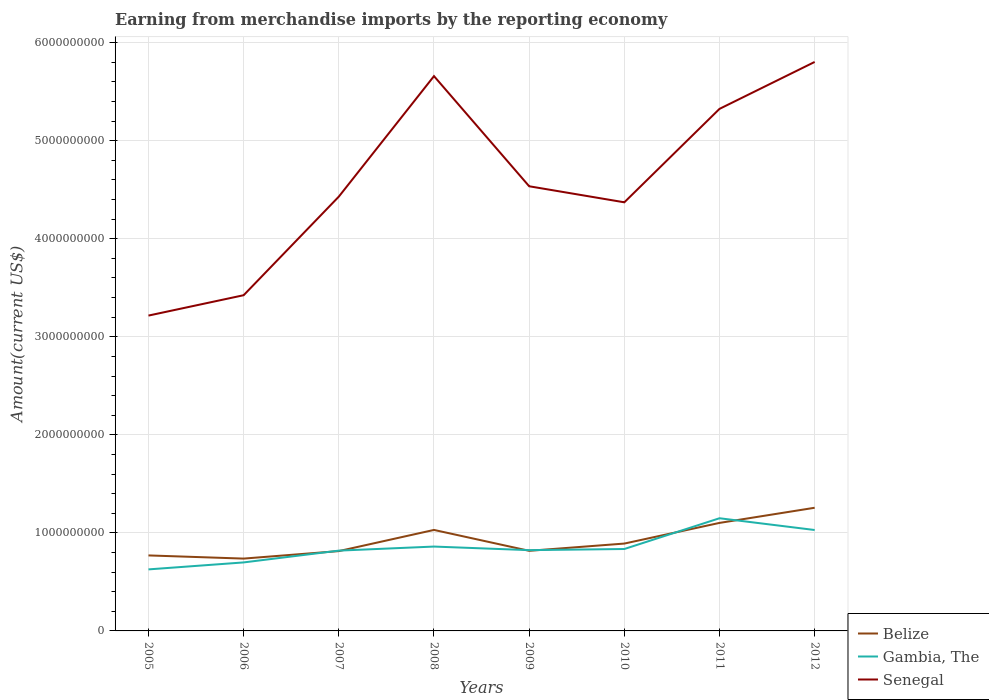Across all years, what is the maximum amount earned from merchandise imports in Belize?
Offer a terse response. 7.38e+08. What is the total amount earned from merchandise imports in Senegal in the graph?
Provide a short and direct response. -2.08e+08. What is the difference between the highest and the second highest amount earned from merchandise imports in Senegal?
Give a very brief answer. 2.59e+09. Is the amount earned from merchandise imports in Senegal strictly greater than the amount earned from merchandise imports in Gambia, The over the years?
Offer a very short reply. No. How many years are there in the graph?
Give a very brief answer. 8. What is the difference between two consecutive major ticks on the Y-axis?
Offer a very short reply. 1.00e+09. Are the values on the major ticks of Y-axis written in scientific E-notation?
Your answer should be very brief. No. Does the graph contain any zero values?
Offer a very short reply. No. How are the legend labels stacked?
Offer a terse response. Vertical. What is the title of the graph?
Provide a short and direct response. Earning from merchandise imports by the reporting economy. Does "Jamaica" appear as one of the legend labels in the graph?
Offer a very short reply. No. What is the label or title of the X-axis?
Provide a succinct answer. Years. What is the label or title of the Y-axis?
Ensure brevity in your answer.  Amount(current US$). What is the Amount(current US$) in Belize in 2005?
Your response must be concise. 7.70e+08. What is the Amount(current US$) of Gambia, The in 2005?
Make the answer very short. 6.28e+08. What is the Amount(current US$) in Senegal in 2005?
Provide a short and direct response. 3.22e+09. What is the Amount(current US$) in Belize in 2006?
Keep it short and to the point. 7.38e+08. What is the Amount(current US$) of Gambia, The in 2006?
Provide a succinct answer. 6.99e+08. What is the Amount(current US$) in Senegal in 2006?
Provide a short and direct response. 3.42e+09. What is the Amount(current US$) in Belize in 2007?
Make the answer very short. 8.14e+08. What is the Amount(current US$) of Gambia, The in 2007?
Provide a short and direct response. 8.19e+08. What is the Amount(current US$) of Senegal in 2007?
Keep it short and to the point. 4.43e+09. What is the Amount(current US$) in Belize in 2008?
Your response must be concise. 1.03e+09. What is the Amount(current US$) in Gambia, The in 2008?
Keep it short and to the point. 8.60e+08. What is the Amount(current US$) of Senegal in 2008?
Your response must be concise. 5.66e+09. What is the Amount(current US$) of Belize in 2009?
Your answer should be compact. 8.17e+08. What is the Amount(current US$) of Gambia, The in 2009?
Provide a short and direct response. 8.24e+08. What is the Amount(current US$) in Senegal in 2009?
Offer a terse response. 4.54e+09. What is the Amount(current US$) in Belize in 2010?
Your answer should be very brief. 8.91e+08. What is the Amount(current US$) in Gambia, The in 2010?
Provide a succinct answer. 8.36e+08. What is the Amount(current US$) in Senegal in 2010?
Keep it short and to the point. 4.37e+09. What is the Amount(current US$) of Belize in 2011?
Your answer should be compact. 1.10e+09. What is the Amount(current US$) in Gambia, The in 2011?
Your response must be concise. 1.15e+09. What is the Amount(current US$) in Senegal in 2011?
Your answer should be very brief. 5.33e+09. What is the Amount(current US$) in Belize in 2012?
Your answer should be compact. 1.26e+09. What is the Amount(current US$) of Gambia, The in 2012?
Your answer should be very brief. 1.03e+09. What is the Amount(current US$) of Senegal in 2012?
Your answer should be very brief. 5.80e+09. Across all years, what is the maximum Amount(current US$) of Belize?
Provide a succinct answer. 1.26e+09. Across all years, what is the maximum Amount(current US$) of Gambia, The?
Your answer should be very brief. 1.15e+09. Across all years, what is the maximum Amount(current US$) in Senegal?
Your answer should be compact. 5.80e+09. Across all years, what is the minimum Amount(current US$) in Belize?
Offer a very short reply. 7.38e+08. Across all years, what is the minimum Amount(current US$) in Gambia, The?
Provide a short and direct response. 6.28e+08. Across all years, what is the minimum Amount(current US$) in Senegal?
Your answer should be very brief. 3.22e+09. What is the total Amount(current US$) in Belize in the graph?
Your answer should be compact. 7.42e+09. What is the total Amount(current US$) in Gambia, The in the graph?
Give a very brief answer. 6.84e+09. What is the total Amount(current US$) of Senegal in the graph?
Keep it short and to the point. 3.68e+1. What is the difference between the Amount(current US$) of Belize in 2005 and that in 2006?
Keep it short and to the point. 3.23e+07. What is the difference between the Amount(current US$) in Gambia, The in 2005 and that in 2006?
Offer a terse response. -7.11e+07. What is the difference between the Amount(current US$) in Senegal in 2005 and that in 2006?
Offer a very short reply. -2.08e+08. What is the difference between the Amount(current US$) of Belize in 2005 and that in 2007?
Offer a very short reply. -4.42e+07. What is the difference between the Amount(current US$) of Gambia, The in 2005 and that in 2007?
Your answer should be compact. -1.91e+08. What is the difference between the Amount(current US$) in Senegal in 2005 and that in 2007?
Offer a terse response. -1.21e+09. What is the difference between the Amount(current US$) in Belize in 2005 and that in 2008?
Make the answer very short. -2.60e+08. What is the difference between the Amount(current US$) in Gambia, The in 2005 and that in 2008?
Your answer should be very brief. -2.33e+08. What is the difference between the Amount(current US$) of Senegal in 2005 and that in 2008?
Your response must be concise. -2.44e+09. What is the difference between the Amount(current US$) in Belize in 2005 and that in 2009?
Offer a terse response. -4.71e+07. What is the difference between the Amount(current US$) of Gambia, The in 2005 and that in 2009?
Make the answer very short. -1.96e+08. What is the difference between the Amount(current US$) of Senegal in 2005 and that in 2009?
Provide a short and direct response. -1.32e+09. What is the difference between the Amount(current US$) of Belize in 2005 and that in 2010?
Make the answer very short. -1.21e+08. What is the difference between the Amount(current US$) in Gambia, The in 2005 and that in 2010?
Keep it short and to the point. -2.08e+08. What is the difference between the Amount(current US$) in Senegal in 2005 and that in 2010?
Keep it short and to the point. -1.16e+09. What is the difference between the Amount(current US$) of Belize in 2005 and that in 2011?
Your answer should be very brief. -3.32e+08. What is the difference between the Amount(current US$) in Gambia, The in 2005 and that in 2011?
Your response must be concise. -5.22e+08. What is the difference between the Amount(current US$) of Senegal in 2005 and that in 2011?
Offer a terse response. -2.11e+09. What is the difference between the Amount(current US$) in Belize in 2005 and that in 2012?
Your answer should be compact. -4.86e+08. What is the difference between the Amount(current US$) of Gambia, The in 2005 and that in 2012?
Your answer should be compact. -4.02e+08. What is the difference between the Amount(current US$) in Senegal in 2005 and that in 2012?
Give a very brief answer. -2.59e+09. What is the difference between the Amount(current US$) of Belize in 2006 and that in 2007?
Provide a short and direct response. -7.64e+07. What is the difference between the Amount(current US$) in Gambia, The in 2006 and that in 2007?
Your answer should be compact. -1.20e+08. What is the difference between the Amount(current US$) of Senegal in 2006 and that in 2007?
Offer a very short reply. -1.01e+09. What is the difference between the Amount(current US$) in Belize in 2006 and that in 2008?
Keep it short and to the point. -2.92e+08. What is the difference between the Amount(current US$) of Gambia, The in 2006 and that in 2008?
Offer a terse response. -1.62e+08. What is the difference between the Amount(current US$) in Senegal in 2006 and that in 2008?
Keep it short and to the point. -2.23e+09. What is the difference between the Amount(current US$) in Belize in 2006 and that in 2009?
Make the answer very short. -7.94e+07. What is the difference between the Amount(current US$) of Gambia, The in 2006 and that in 2009?
Your response must be concise. -1.25e+08. What is the difference between the Amount(current US$) in Senegal in 2006 and that in 2009?
Make the answer very short. -1.11e+09. What is the difference between the Amount(current US$) in Belize in 2006 and that in 2010?
Your answer should be very brief. -1.53e+08. What is the difference between the Amount(current US$) in Gambia, The in 2006 and that in 2010?
Offer a terse response. -1.37e+08. What is the difference between the Amount(current US$) in Senegal in 2006 and that in 2010?
Give a very brief answer. -9.48e+08. What is the difference between the Amount(current US$) of Belize in 2006 and that in 2011?
Provide a short and direct response. -3.64e+08. What is the difference between the Amount(current US$) in Gambia, The in 2006 and that in 2011?
Your response must be concise. -4.51e+08. What is the difference between the Amount(current US$) in Senegal in 2006 and that in 2011?
Ensure brevity in your answer.  -1.90e+09. What is the difference between the Amount(current US$) in Belize in 2006 and that in 2012?
Make the answer very short. -5.18e+08. What is the difference between the Amount(current US$) in Gambia, The in 2006 and that in 2012?
Offer a terse response. -3.31e+08. What is the difference between the Amount(current US$) of Senegal in 2006 and that in 2012?
Provide a succinct answer. -2.38e+09. What is the difference between the Amount(current US$) of Belize in 2007 and that in 2008?
Keep it short and to the point. -2.16e+08. What is the difference between the Amount(current US$) of Gambia, The in 2007 and that in 2008?
Give a very brief answer. -4.14e+07. What is the difference between the Amount(current US$) of Senegal in 2007 and that in 2008?
Provide a succinct answer. -1.23e+09. What is the difference between the Amount(current US$) in Belize in 2007 and that in 2009?
Keep it short and to the point. -2.95e+06. What is the difference between the Amount(current US$) in Gambia, The in 2007 and that in 2009?
Provide a succinct answer. -4.97e+06. What is the difference between the Amount(current US$) of Senegal in 2007 and that in 2009?
Give a very brief answer. -1.05e+08. What is the difference between the Amount(current US$) in Belize in 2007 and that in 2010?
Keep it short and to the point. -7.68e+07. What is the difference between the Amount(current US$) of Gambia, The in 2007 and that in 2010?
Offer a very short reply. -1.66e+07. What is the difference between the Amount(current US$) in Senegal in 2007 and that in 2010?
Your answer should be compact. 5.82e+07. What is the difference between the Amount(current US$) of Belize in 2007 and that in 2011?
Offer a very short reply. -2.88e+08. What is the difference between the Amount(current US$) in Gambia, The in 2007 and that in 2011?
Offer a terse response. -3.30e+08. What is the difference between the Amount(current US$) of Senegal in 2007 and that in 2011?
Give a very brief answer. -8.95e+08. What is the difference between the Amount(current US$) of Belize in 2007 and that in 2012?
Keep it short and to the point. -4.42e+08. What is the difference between the Amount(current US$) in Gambia, The in 2007 and that in 2012?
Your response must be concise. -2.10e+08. What is the difference between the Amount(current US$) in Senegal in 2007 and that in 2012?
Provide a short and direct response. -1.37e+09. What is the difference between the Amount(current US$) in Belize in 2008 and that in 2009?
Give a very brief answer. 2.13e+08. What is the difference between the Amount(current US$) in Gambia, The in 2008 and that in 2009?
Offer a very short reply. 3.64e+07. What is the difference between the Amount(current US$) in Senegal in 2008 and that in 2009?
Make the answer very short. 1.12e+09. What is the difference between the Amount(current US$) of Belize in 2008 and that in 2010?
Offer a very short reply. 1.39e+08. What is the difference between the Amount(current US$) in Gambia, The in 2008 and that in 2010?
Ensure brevity in your answer.  2.48e+07. What is the difference between the Amount(current US$) in Senegal in 2008 and that in 2010?
Your answer should be very brief. 1.29e+09. What is the difference between the Amount(current US$) in Belize in 2008 and that in 2011?
Keep it short and to the point. -7.16e+07. What is the difference between the Amount(current US$) in Gambia, The in 2008 and that in 2011?
Give a very brief answer. -2.89e+08. What is the difference between the Amount(current US$) in Senegal in 2008 and that in 2011?
Keep it short and to the point. 3.34e+08. What is the difference between the Amount(current US$) in Belize in 2008 and that in 2012?
Offer a terse response. -2.26e+08. What is the difference between the Amount(current US$) in Gambia, The in 2008 and that in 2012?
Keep it short and to the point. -1.69e+08. What is the difference between the Amount(current US$) of Senegal in 2008 and that in 2012?
Your answer should be compact. -1.45e+08. What is the difference between the Amount(current US$) in Belize in 2009 and that in 2010?
Your answer should be very brief. -7.39e+07. What is the difference between the Amount(current US$) of Gambia, The in 2009 and that in 2010?
Your answer should be compact. -1.16e+07. What is the difference between the Amount(current US$) of Senegal in 2009 and that in 2010?
Your answer should be compact. 1.64e+08. What is the difference between the Amount(current US$) of Belize in 2009 and that in 2011?
Your answer should be compact. -2.85e+08. What is the difference between the Amount(current US$) of Gambia, The in 2009 and that in 2011?
Ensure brevity in your answer.  -3.25e+08. What is the difference between the Amount(current US$) in Senegal in 2009 and that in 2011?
Your answer should be compact. -7.89e+08. What is the difference between the Amount(current US$) in Belize in 2009 and that in 2012?
Make the answer very short. -4.39e+08. What is the difference between the Amount(current US$) of Gambia, The in 2009 and that in 2012?
Give a very brief answer. -2.05e+08. What is the difference between the Amount(current US$) of Senegal in 2009 and that in 2012?
Make the answer very short. -1.27e+09. What is the difference between the Amount(current US$) in Belize in 2010 and that in 2011?
Offer a very short reply. -2.11e+08. What is the difference between the Amount(current US$) of Gambia, The in 2010 and that in 2011?
Make the answer very short. -3.14e+08. What is the difference between the Amount(current US$) of Senegal in 2010 and that in 2011?
Provide a short and direct response. -9.53e+08. What is the difference between the Amount(current US$) of Belize in 2010 and that in 2012?
Ensure brevity in your answer.  -3.65e+08. What is the difference between the Amount(current US$) of Gambia, The in 2010 and that in 2012?
Your answer should be very brief. -1.94e+08. What is the difference between the Amount(current US$) of Senegal in 2010 and that in 2012?
Your response must be concise. -1.43e+09. What is the difference between the Amount(current US$) in Belize in 2011 and that in 2012?
Make the answer very short. -1.54e+08. What is the difference between the Amount(current US$) in Gambia, The in 2011 and that in 2012?
Offer a very short reply. 1.20e+08. What is the difference between the Amount(current US$) of Senegal in 2011 and that in 2012?
Ensure brevity in your answer.  -4.79e+08. What is the difference between the Amount(current US$) in Belize in 2005 and the Amount(current US$) in Gambia, The in 2006?
Provide a short and direct response. 7.13e+07. What is the difference between the Amount(current US$) of Belize in 2005 and the Amount(current US$) of Senegal in 2006?
Ensure brevity in your answer.  -2.65e+09. What is the difference between the Amount(current US$) of Gambia, The in 2005 and the Amount(current US$) of Senegal in 2006?
Give a very brief answer. -2.80e+09. What is the difference between the Amount(current US$) in Belize in 2005 and the Amount(current US$) in Gambia, The in 2007?
Provide a short and direct response. -4.89e+07. What is the difference between the Amount(current US$) in Belize in 2005 and the Amount(current US$) in Senegal in 2007?
Provide a succinct answer. -3.66e+09. What is the difference between the Amount(current US$) of Gambia, The in 2005 and the Amount(current US$) of Senegal in 2007?
Offer a terse response. -3.80e+09. What is the difference between the Amount(current US$) of Belize in 2005 and the Amount(current US$) of Gambia, The in 2008?
Ensure brevity in your answer.  -9.03e+07. What is the difference between the Amount(current US$) in Belize in 2005 and the Amount(current US$) in Senegal in 2008?
Your answer should be compact. -4.89e+09. What is the difference between the Amount(current US$) of Gambia, The in 2005 and the Amount(current US$) of Senegal in 2008?
Your response must be concise. -5.03e+09. What is the difference between the Amount(current US$) in Belize in 2005 and the Amount(current US$) in Gambia, The in 2009?
Your answer should be very brief. -5.39e+07. What is the difference between the Amount(current US$) of Belize in 2005 and the Amount(current US$) of Senegal in 2009?
Offer a terse response. -3.77e+09. What is the difference between the Amount(current US$) in Gambia, The in 2005 and the Amount(current US$) in Senegal in 2009?
Give a very brief answer. -3.91e+09. What is the difference between the Amount(current US$) in Belize in 2005 and the Amount(current US$) in Gambia, The in 2010?
Offer a terse response. -6.55e+07. What is the difference between the Amount(current US$) of Belize in 2005 and the Amount(current US$) of Senegal in 2010?
Your response must be concise. -3.60e+09. What is the difference between the Amount(current US$) in Gambia, The in 2005 and the Amount(current US$) in Senegal in 2010?
Your response must be concise. -3.74e+09. What is the difference between the Amount(current US$) of Belize in 2005 and the Amount(current US$) of Gambia, The in 2011?
Ensure brevity in your answer.  -3.79e+08. What is the difference between the Amount(current US$) in Belize in 2005 and the Amount(current US$) in Senegal in 2011?
Offer a terse response. -4.55e+09. What is the difference between the Amount(current US$) in Gambia, The in 2005 and the Amount(current US$) in Senegal in 2011?
Your answer should be compact. -4.70e+09. What is the difference between the Amount(current US$) of Belize in 2005 and the Amount(current US$) of Gambia, The in 2012?
Provide a short and direct response. -2.59e+08. What is the difference between the Amount(current US$) in Belize in 2005 and the Amount(current US$) in Senegal in 2012?
Make the answer very short. -5.03e+09. What is the difference between the Amount(current US$) of Gambia, The in 2005 and the Amount(current US$) of Senegal in 2012?
Provide a succinct answer. -5.18e+09. What is the difference between the Amount(current US$) of Belize in 2006 and the Amount(current US$) of Gambia, The in 2007?
Keep it short and to the point. -8.12e+07. What is the difference between the Amount(current US$) of Belize in 2006 and the Amount(current US$) of Senegal in 2007?
Give a very brief answer. -3.69e+09. What is the difference between the Amount(current US$) in Gambia, The in 2006 and the Amount(current US$) in Senegal in 2007?
Your answer should be compact. -3.73e+09. What is the difference between the Amount(current US$) in Belize in 2006 and the Amount(current US$) in Gambia, The in 2008?
Provide a succinct answer. -1.23e+08. What is the difference between the Amount(current US$) in Belize in 2006 and the Amount(current US$) in Senegal in 2008?
Your answer should be compact. -4.92e+09. What is the difference between the Amount(current US$) of Gambia, The in 2006 and the Amount(current US$) of Senegal in 2008?
Provide a short and direct response. -4.96e+09. What is the difference between the Amount(current US$) in Belize in 2006 and the Amount(current US$) in Gambia, The in 2009?
Your response must be concise. -8.62e+07. What is the difference between the Amount(current US$) in Belize in 2006 and the Amount(current US$) in Senegal in 2009?
Provide a succinct answer. -3.80e+09. What is the difference between the Amount(current US$) of Gambia, The in 2006 and the Amount(current US$) of Senegal in 2009?
Ensure brevity in your answer.  -3.84e+09. What is the difference between the Amount(current US$) in Belize in 2006 and the Amount(current US$) in Gambia, The in 2010?
Offer a terse response. -9.78e+07. What is the difference between the Amount(current US$) of Belize in 2006 and the Amount(current US$) of Senegal in 2010?
Provide a short and direct response. -3.63e+09. What is the difference between the Amount(current US$) of Gambia, The in 2006 and the Amount(current US$) of Senegal in 2010?
Provide a short and direct response. -3.67e+09. What is the difference between the Amount(current US$) of Belize in 2006 and the Amount(current US$) of Gambia, The in 2011?
Your answer should be very brief. -4.11e+08. What is the difference between the Amount(current US$) in Belize in 2006 and the Amount(current US$) in Senegal in 2011?
Offer a terse response. -4.59e+09. What is the difference between the Amount(current US$) in Gambia, The in 2006 and the Amount(current US$) in Senegal in 2011?
Offer a terse response. -4.63e+09. What is the difference between the Amount(current US$) in Belize in 2006 and the Amount(current US$) in Gambia, The in 2012?
Your answer should be very brief. -2.92e+08. What is the difference between the Amount(current US$) in Belize in 2006 and the Amount(current US$) in Senegal in 2012?
Give a very brief answer. -5.07e+09. What is the difference between the Amount(current US$) in Gambia, The in 2006 and the Amount(current US$) in Senegal in 2012?
Make the answer very short. -5.10e+09. What is the difference between the Amount(current US$) in Belize in 2007 and the Amount(current US$) in Gambia, The in 2008?
Your response must be concise. -4.62e+07. What is the difference between the Amount(current US$) in Belize in 2007 and the Amount(current US$) in Senegal in 2008?
Provide a short and direct response. -4.84e+09. What is the difference between the Amount(current US$) in Gambia, The in 2007 and the Amount(current US$) in Senegal in 2008?
Offer a very short reply. -4.84e+09. What is the difference between the Amount(current US$) of Belize in 2007 and the Amount(current US$) of Gambia, The in 2009?
Give a very brief answer. -9.74e+06. What is the difference between the Amount(current US$) of Belize in 2007 and the Amount(current US$) of Senegal in 2009?
Your answer should be compact. -3.72e+09. What is the difference between the Amount(current US$) in Gambia, The in 2007 and the Amount(current US$) in Senegal in 2009?
Your answer should be very brief. -3.72e+09. What is the difference between the Amount(current US$) of Belize in 2007 and the Amount(current US$) of Gambia, The in 2010?
Your answer should be very brief. -2.14e+07. What is the difference between the Amount(current US$) in Belize in 2007 and the Amount(current US$) in Senegal in 2010?
Give a very brief answer. -3.56e+09. What is the difference between the Amount(current US$) of Gambia, The in 2007 and the Amount(current US$) of Senegal in 2010?
Your answer should be very brief. -3.55e+09. What is the difference between the Amount(current US$) of Belize in 2007 and the Amount(current US$) of Gambia, The in 2011?
Give a very brief answer. -3.35e+08. What is the difference between the Amount(current US$) of Belize in 2007 and the Amount(current US$) of Senegal in 2011?
Keep it short and to the point. -4.51e+09. What is the difference between the Amount(current US$) in Gambia, The in 2007 and the Amount(current US$) in Senegal in 2011?
Make the answer very short. -4.51e+09. What is the difference between the Amount(current US$) of Belize in 2007 and the Amount(current US$) of Gambia, The in 2012?
Make the answer very short. -2.15e+08. What is the difference between the Amount(current US$) in Belize in 2007 and the Amount(current US$) in Senegal in 2012?
Offer a very short reply. -4.99e+09. What is the difference between the Amount(current US$) of Gambia, The in 2007 and the Amount(current US$) of Senegal in 2012?
Keep it short and to the point. -4.98e+09. What is the difference between the Amount(current US$) in Belize in 2008 and the Amount(current US$) in Gambia, The in 2009?
Provide a short and direct response. 2.06e+08. What is the difference between the Amount(current US$) of Belize in 2008 and the Amount(current US$) of Senegal in 2009?
Keep it short and to the point. -3.51e+09. What is the difference between the Amount(current US$) in Gambia, The in 2008 and the Amount(current US$) in Senegal in 2009?
Your answer should be very brief. -3.68e+09. What is the difference between the Amount(current US$) in Belize in 2008 and the Amount(current US$) in Gambia, The in 2010?
Offer a very short reply. 1.95e+08. What is the difference between the Amount(current US$) in Belize in 2008 and the Amount(current US$) in Senegal in 2010?
Offer a very short reply. -3.34e+09. What is the difference between the Amount(current US$) of Gambia, The in 2008 and the Amount(current US$) of Senegal in 2010?
Offer a very short reply. -3.51e+09. What is the difference between the Amount(current US$) in Belize in 2008 and the Amount(current US$) in Gambia, The in 2011?
Give a very brief answer. -1.19e+08. What is the difference between the Amount(current US$) of Belize in 2008 and the Amount(current US$) of Senegal in 2011?
Provide a short and direct response. -4.29e+09. What is the difference between the Amount(current US$) in Gambia, The in 2008 and the Amount(current US$) in Senegal in 2011?
Your answer should be compact. -4.46e+09. What is the difference between the Amount(current US$) in Belize in 2008 and the Amount(current US$) in Gambia, The in 2012?
Provide a succinct answer. 7.79e+05. What is the difference between the Amount(current US$) of Belize in 2008 and the Amount(current US$) of Senegal in 2012?
Make the answer very short. -4.77e+09. What is the difference between the Amount(current US$) of Gambia, The in 2008 and the Amount(current US$) of Senegal in 2012?
Offer a terse response. -4.94e+09. What is the difference between the Amount(current US$) of Belize in 2009 and the Amount(current US$) of Gambia, The in 2010?
Offer a terse response. -1.84e+07. What is the difference between the Amount(current US$) of Belize in 2009 and the Amount(current US$) of Senegal in 2010?
Your response must be concise. -3.55e+09. What is the difference between the Amount(current US$) of Gambia, The in 2009 and the Amount(current US$) of Senegal in 2010?
Provide a short and direct response. -3.55e+09. What is the difference between the Amount(current US$) in Belize in 2009 and the Amount(current US$) in Gambia, The in 2011?
Provide a short and direct response. -3.32e+08. What is the difference between the Amount(current US$) of Belize in 2009 and the Amount(current US$) of Senegal in 2011?
Offer a very short reply. -4.51e+09. What is the difference between the Amount(current US$) in Gambia, The in 2009 and the Amount(current US$) in Senegal in 2011?
Your answer should be very brief. -4.50e+09. What is the difference between the Amount(current US$) in Belize in 2009 and the Amount(current US$) in Gambia, The in 2012?
Your answer should be very brief. -2.12e+08. What is the difference between the Amount(current US$) of Belize in 2009 and the Amount(current US$) of Senegal in 2012?
Your response must be concise. -4.99e+09. What is the difference between the Amount(current US$) of Gambia, The in 2009 and the Amount(current US$) of Senegal in 2012?
Ensure brevity in your answer.  -4.98e+09. What is the difference between the Amount(current US$) in Belize in 2010 and the Amount(current US$) in Gambia, The in 2011?
Offer a terse response. -2.58e+08. What is the difference between the Amount(current US$) in Belize in 2010 and the Amount(current US$) in Senegal in 2011?
Make the answer very short. -4.43e+09. What is the difference between the Amount(current US$) in Gambia, The in 2010 and the Amount(current US$) in Senegal in 2011?
Give a very brief answer. -4.49e+09. What is the difference between the Amount(current US$) in Belize in 2010 and the Amount(current US$) in Gambia, The in 2012?
Offer a terse response. -1.38e+08. What is the difference between the Amount(current US$) in Belize in 2010 and the Amount(current US$) in Senegal in 2012?
Ensure brevity in your answer.  -4.91e+09. What is the difference between the Amount(current US$) in Gambia, The in 2010 and the Amount(current US$) in Senegal in 2012?
Offer a terse response. -4.97e+09. What is the difference between the Amount(current US$) of Belize in 2011 and the Amount(current US$) of Gambia, The in 2012?
Provide a succinct answer. 7.24e+07. What is the difference between the Amount(current US$) in Belize in 2011 and the Amount(current US$) in Senegal in 2012?
Provide a succinct answer. -4.70e+09. What is the difference between the Amount(current US$) in Gambia, The in 2011 and the Amount(current US$) in Senegal in 2012?
Your answer should be very brief. -4.65e+09. What is the average Amount(current US$) in Belize per year?
Offer a terse response. 9.27e+08. What is the average Amount(current US$) in Gambia, The per year?
Your response must be concise. 8.56e+08. What is the average Amount(current US$) of Senegal per year?
Provide a short and direct response. 4.60e+09. In the year 2005, what is the difference between the Amount(current US$) of Belize and Amount(current US$) of Gambia, The?
Offer a very short reply. 1.42e+08. In the year 2005, what is the difference between the Amount(current US$) in Belize and Amount(current US$) in Senegal?
Offer a very short reply. -2.45e+09. In the year 2005, what is the difference between the Amount(current US$) of Gambia, The and Amount(current US$) of Senegal?
Provide a succinct answer. -2.59e+09. In the year 2006, what is the difference between the Amount(current US$) in Belize and Amount(current US$) in Gambia, The?
Your response must be concise. 3.91e+07. In the year 2006, what is the difference between the Amount(current US$) of Belize and Amount(current US$) of Senegal?
Provide a short and direct response. -2.69e+09. In the year 2006, what is the difference between the Amount(current US$) in Gambia, The and Amount(current US$) in Senegal?
Provide a short and direct response. -2.73e+09. In the year 2007, what is the difference between the Amount(current US$) of Belize and Amount(current US$) of Gambia, The?
Your response must be concise. -4.77e+06. In the year 2007, what is the difference between the Amount(current US$) of Belize and Amount(current US$) of Senegal?
Your answer should be very brief. -3.62e+09. In the year 2007, what is the difference between the Amount(current US$) in Gambia, The and Amount(current US$) in Senegal?
Offer a terse response. -3.61e+09. In the year 2008, what is the difference between the Amount(current US$) of Belize and Amount(current US$) of Gambia, The?
Provide a succinct answer. 1.70e+08. In the year 2008, what is the difference between the Amount(current US$) of Belize and Amount(current US$) of Senegal?
Your answer should be very brief. -4.63e+09. In the year 2008, what is the difference between the Amount(current US$) of Gambia, The and Amount(current US$) of Senegal?
Offer a terse response. -4.80e+09. In the year 2009, what is the difference between the Amount(current US$) of Belize and Amount(current US$) of Gambia, The?
Provide a succinct answer. -6.79e+06. In the year 2009, what is the difference between the Amount(current US$) of Belize and Amount(current US$) of Senegal?
Your answer should be very brief. -3.72e+09. In the year 2009, what is the difference between the Amount(current US$) of Gambia, The and Amount(current US$) of Senegal?
Keep it short and to the point. -3.71e+09. In the year 2010, what is the difference between the Amount(current US$) in Belize and Amount(current US$) in Gambia, The?
Your response must be concise. 5.54e+07. In the year 2010, what is the difference between the Amount(current US$) of Belize and Amount(current US$) of Senegal?
Ensure brevity in your answer.  -3.48e+09. In the year 2010, what is the difference between the Amount(current US$) in Gambia, The and Amount(current US$) in Senegal?
Your answer should be very brief. -3.54e+09. In the year 2011, what is the difference between the Amount(current US$) of Belize and Amount(current US$) of Gambia, The?
Provide a short and direct response. -4.75e+07. In the year 2011, what is the difference between the Amount(current US$) of Belize and Amount(current US$) of Senegal?
Keep it short and to the point. -4.22e+09. In the year 2011, what is the difference between the Amount(current US$) in Gambia, The and Amount(current US$) in Senegal?
Keep it short and to the point. -4.18e+09. In the year 2012, what is the difference between the Amount(current US$) of Belize and Amount(current US$) of Gambia, The?
Provide a short and direct response. 2.27e+08. In the year 2012, what is the difference between the Amount(current US$) of Belize and Amount(current US$) of Senegal?
Your answer should be compact. -4.55e+09. In the year 2012, what is the difference between the Amount(current US$) in Gambia, The and Amount(current US$) in Senegal?
Provide a short and direct response. -4.77e+09. What is the ratio of the Amount(current US$) of Belize in 2005 to that in 2006?
Provide a short and direct response. 1.04. What is the ratio of the Amount(current US$) of Gambia, The in 2005 to that in 2006?
Your answer should be very brief. 0.9. What is the ratio of the Amount(current US$) in Senegal in 2005 to that in 2006?
Offer a very short reply. 0.94. What is the ratio of the Amount(current US$) of Belize in 2005 to that in 2007?
Provide a short and direct response. 0.95. What is the ratio of the Amount(current US$) of Gambia, The in 2005 to that in 2007?
Your response must be concise. 0.77. What is the ratio of the Amount(current US$) of Senegal in 2005 to that in 2007?
Offer a very short reply. 0.73. What is the ratio of the Amount(current US$) of Belize in 2005 to that in 2008?
Your answer should be compact. 0.75. What is the ratio of the Amount(current US$) in Gambia, The in 2005 to that in 2008?
Your answer should be compact. 0.73. What is the ratio of the Amount(current US$) of Senegal in 2005 to that in 2008?
Your response must be concise. 0.57. What is the ratio of the Amount(current US$) in Belize in 2005 to that in 2009?
Offer a terse response. 0.94. What is the ratio of the Amount(current US$) of Gambia, The in 2005 to that in 2009?
Ensure brevity in your answer.  0.76. What is the ratio of the Amount(current US$) of Senegal in 2005 to that in 2009?
Ensure brevity in your answer.  0.71. What is the ratio of the Amount(current US$) of Belize in 2005 to that in 2010?
Your answer should be very brief. 0.86. What is the ratio of the Amount(current US$) in Gambia, The in 2005 to that in 2010?
Offer a terse response. 0.75. What is the ratio of the Amount(current US$) in Senegal in 2005 to that in 2010?
Your response must be concise. 0.74. What is the ratio of the Amount(current US$) of Belize in 2005 to that in 2011?
Offer a very short reply. 0.7. What is the ratio of the Amount(current US$) of Gambia, The in 2005 to that in 2011?
Offer a very short reply. 0.55. What is the ratio of the Amount(current US$) in Senegal in 2005 to that in 2011?
Give a very brief answer. 0.6. What is the ratio of the Amount(current US$) in Belize in 2005 to that in 2012?
Your answer should be compact. 0.61. What is the ratio of the Amount(current US$) of Gambia, The in 2005 to that in 2012?
Keep it short and to the point. 0.61. What is the ratio of the Amount(current US$) of Senegal in 2005 to that in 2012?
Make the answer very short. 0.55. What is the ratio of the Amount(current US$) of Belize in 2006 to that in 2007?
Your response must be concise. 0.91. What is the ratio of the Amount(current US$) of Gambia, The in 2006 to that in 2007?
Offer a terse response. 0.85. What is the ratio of the Amount(current US$) of Senegal in 2006 to that in 2007?
Make the answer very short. 0.77. What is the ratio of the Amount(current US$) in Belize in 2006 to that in 2008?
Offer a terse response. 0.72. What is the ratio of the Amount(current US$) of Gambia, The in 2006 to that in 2008?
Ensure brevity in your answer.  0.81. What is the ratio of the Amount(current US$) in Senegal in 2006 to that in 2008?
Your response must be concise. 0.61. What is the ratio of the Amount(current US$) of Belize in 2006 to that in 2009?
Give a very brief answer. 0.9. What is the ratio of the Amount(current US$) in Gambia, The in 2006 to that in 2009?
Give a very brief answer. 0.85. What is the ratio of the Amount(current US$) of Senegal in 2006 to that in 2009?
Provide a succinct answer. 0.76. What is the ratio of the Amount(current US$) of Belize in 2006 to that in 2010?
Keep it short and to the point. 0.83. What is the ratio of the Amount(current US$) in Gambia, The in 2006 to that in 2010?
Keep it short and to the point. 0.84. What is the ratio of the Amount(current US$) of Senegal in 2006 to that in 2010?
Your answer should be compact. 0.78. What is the ratio of the Amount(current US$) of Belize in 2006 to that in 2011?
Your answer should be compact. 0.67. What is the ratio of the Amount(current US$) in Gambia, The in 2006 to that in 2011?
Your answer should be very brief. 0.61. What is the ratio of the Amount(current US$) of Senegal in 2006 to that in 2011?
Make the answer very short. 0.64. What is the ratio of the Amount(current US$) of Belize in 2006 to that in 2012?
Give a very brief answer. 0.59. What is the ratio of the Amount(current US$) of Gambia, The in 2006 to that in 2012?
Provide a succinct answer. 0.68. What is the ratio of the Amount(current US$) of Senegal in 2006 to that in 2012?
Make the answer very short. 0.59. What is the ratio of the Amount(current US$) of Belize in 2007 to that in 2008?
Your answer should be very brief. 0.79. What is the ratio of the Amount(current US$) of Gambia, The in 2007 to that in 2008?
Offer a terse response. 0.95. What is the ratio of the Amount(current US$) in Senegal in 2007 to that in 2008?
Your answer should be very brief. 0.78. What is the ratio of the Amount(current US$) of Senegal in 2007 to that in 2009?
Ensure brevity in your answer.  0.98. What is the ratio of the Amount(current US$) in Belize in 2007 to that in 2010?
Offer a terse response. 0.91. What is the ratio of the Amount(current US$) in Gambia, The in 2007 to that in 2010?
Offer a very short reply. 0.98. What is the ratio of the Amount(current US$) in Senegal in 2007 to that in 2010?
Your response must be concise. 1.01. What is the ratio of the Amount(current US$) of Belize in 2007 to that in 2011?
Give a very brief answer. 0.74. What is the ratio of the Amount(current US$) of Gambia, The in 2007 to that in 2011?
Make the answer very short. 0.71. What is the ratio of the Amount(current US$) in Senegal in 2007 to that in 2011?
Your answer should be compact. 0.83. What is the ratio of the Amount(current US$) of Belize in 2007 to that in 2012?
Offer a very short reply. 0.65. What is the ratio of the Amount(current US$) in Gambia, The in 2007 to that in 2012?
Your answer should be very brief. 0.8. What is the ratio of the Amount(current US$) in Senegal in 2007 to that in 2012?
Keep it short and to the point. 0.76. What is the ratio of the Amount(current US$) in Belize in 2008 to that in 2009?
Ensure brevity in your answer.  1.26. What is the ratio of the Amount(current US$) of Gambia, The in 2008 to that in 2009?
Offer a terse response. 1.04. What is the ratio of the Amount(current US$) of Senegal in 2008 to that in 2009?
Provide a succinct answer. 1.25. What is the ratio of the Amount(current US$) of Belize in 2008 to that in 2010?
Your response must be concise. 1.16. What is the ratio of the Amount(current US$) in Gambia, The in 2008 to that in 2010?
Offer a terse response. 1.03. What is the ratio of the Amount(current US$) of Senegal in 2008 to that in 2010?
Make the answer very short. 1.29. What is the ratio of the Amount(current US$) in Belize in 2008 to that in 2011?
Make the answer very short. 0.94. What is the ratio of the Amount(current US$) in Gambia, The in 2008 to that in 2011?
Ensure brevity in your answer.  0.75. What is the ratio of the Amount(current US$) in Senegal in 2008 to that in 2011?
Your answer should be very brief. 1.06. What is the ratio of the Amount(current US$) in Belize in 2008 to that in 2012?
Keep it short and to the point. 0.82. What is the ratio of the Amount(current US$) of Gambia, The in 2008 to that in 2012?
Offer a terse response. 0.84. What is the ratio of the Amount(current US$) of Senegal in 2008 to that in 2012?
Provide a short and direct response. 0.98. What is the ratio of the Amount(current US$) in Belize in 2009 to that in 2010?
Your answer should be very brief. 0.92. What is the ratio of the Amount(current US$) of Gambia, The in 2009 to that in 2010?
Your answer should be compact. 0.99. What is the ratio of the Amount(current US$) of Senegal in 2009 to that in 2010?
Offer a terse response. 1.04. What is the ratio of the Amount(current US$) of Belize in 2009 to that in 2011?
Ensure brevity in your answer.  0.74. What is the ratio of the Amount(current US$) of Gambia, The in 2009 to that in 2011?
Give a very brief answer. 0.72. What is the ratio of the Amount(current US$) in Senegal in 2009 to that in 2011?
Provide a short and direct response. 0.85. What is the ratio of the Amount(current US$) of Belize in 2009 to that in 2012?
Make the answer very short. 0.65. What is the ratio of the Amount(current US$) of Gambia, The in 2009 to that in 2012?
Ensure brevity in your answer.  0.8. What is the ratio of the Amount(current US$) of Senegal in 2009 to that in 2012?
Give a very brief answer. 0.78. What is the ratio of the Amount(current US$) in Belize in 2010 to that in 2011?
Give a very brief answer. 0.81. What is the ratio of the Amount(current US$) in Gambia, The in 2010 to that in 2011?
Provide a succinct answer. 0.73. What is the ratio of the Amount(current US$) of Senegal in 2010 to that in 2011?
Ensure brevity in your answer.  0.82. What is the ratio of the Amount(current US$) in Belize in 2010 to that in 2012?
Your answer should be very brief. 0.71. What is the ratio of the Amount(current US$) of Gambia, The in 2010 to that in 2012?
Offer a very short reply. 0.81. What is the ratio of the Amount(current US$) in Senegal in 2010 to that in 2012?
Provide a succinct answer. 0.75. What is the ratio of the Amount(current US$) of Belize in 2011 to that in 2012?
Your response must be concise. 0.88. What is the ratio of the Amount(current US$) of Gambia, The in 2011 to that in 2012?
Your answer should be very brief. 1.12. What is the ratio of the Amount(current US$) in Senegal in 2011 to that in 2012?
Ensure brevity in your answer.  0.92. What is the difference between the highest and the second highest Amount(current US$) of Belize?
Your response must be concise. 1.54e+08. What is the difference between the highest and the second highest Amount(current US$) in Gambia, The?
Offer a very short reply. 1.20e+08. What is the difference between the highest and the second highest Amount(current US$) in Senegal?
Keep it short and to the point. 1.45e+08. What is the difference between the highest and the lowest Amount(current US$) of Belize?
Give a very brief answer. 5.18e+08. What is the difference between the highest and the lowest Amount(current US$) of Gambia, The?
Your response must be concise. 5.22e+08. What is the difference between the highest and the lowest Amount(current US$) in Senegal?
Your response must be concise. 2.59e+09. 